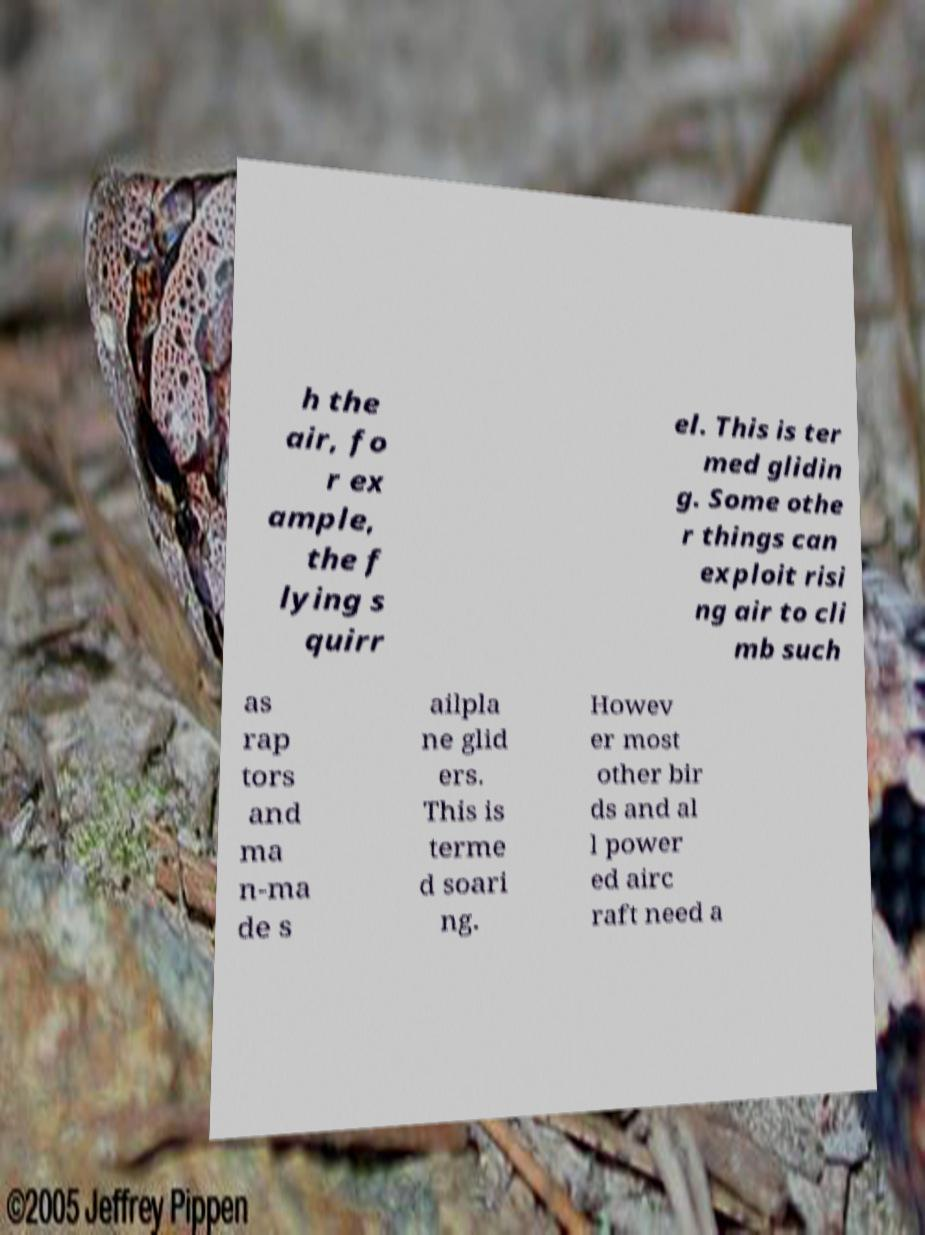Please read and relay the text visible in this image. What does it say? h the air, fo r ex ample, the f lying s quirr el. This is ter med glidin g. Some othe r things can exploit risi ng air to cli mb such as rap tors and ma n-ma de s ailpla ne glid ers. This is terme d soari ng. Howev er most other bir ds and al l power ed airc raft need a 